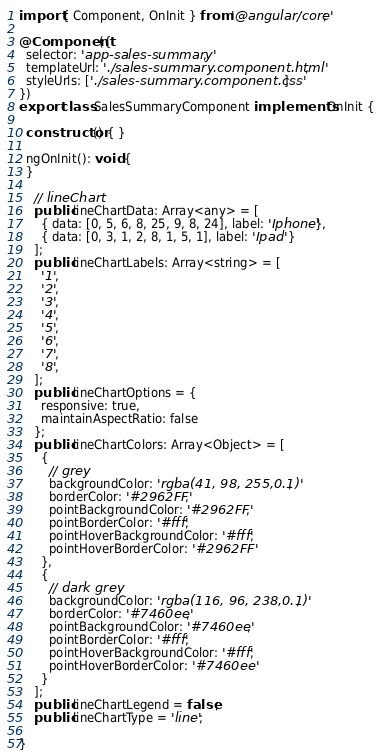<code> <loc_0><loc_0><loc_500><loc_500><_TypeScript_>import { Component, OnInit } from '@angular/core';

@Component({
  selector: 'app-sales-summary',
  templateUrl: './sales-summary.component.html',
  styleUrls: ['./sales-summary.component.css']
})
export class SalesSummaryComponent implements OnInit {

  constructor() { }

  ngOnInit(): void {
  }

    // lineChart
    public lineChartData: Array<any> = [
      { data: [0, 5, 6, 8, 25, 9, 8, 24], label: 'Iphone'},
      { data: [0, 3, 1, 2, 8, 1, 5, 1], label: 'Ipad' }
    ];
    public lineChartLabels: Array<string> = [
      '1',
      '2',
      '3',
      '4',
      '5',
      '6',
      '7',
      '8',
    ];
    public lineChartOptions = {
      responsive: true,
      maintainAspectRatio: false
    };
    public lineChartColors: Array<Object> = [
      {
        // grey
        backgroundColor: 'rgba(41, 98, 255,0.1)',
        borderColor: '#2962FF',
        pointBackgroundColor: '#2962FF',
        pointBorderColor: '#fff',
        pointHoverBackgroundColor: '#fff',
        pointHoverBorderColor: '#2962FF'
      },
      {
        // dark grey
        backgroundColor: 'rgba(116, 96, 238,0.1)',
        borderColor: '#7460ee',
        pointBackgroundColor: '#7460ee',
        pointBorderColor: '#fff',
        pointHoverBackgroundColor: '#fff',
        pointHoverBorderColor: '#7460ee'
      }
    ];
    public lineChartLegend = false;
    public lineChartType = 'line';

}
</code> 